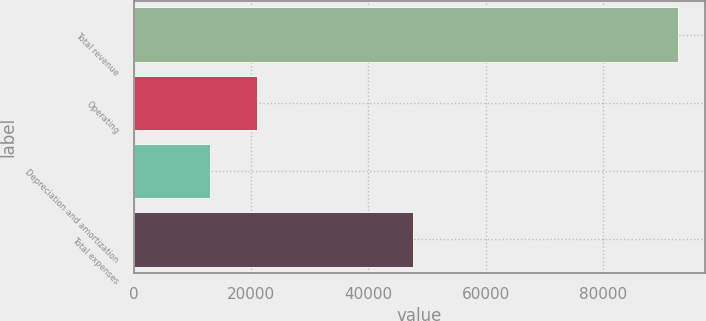Convert chart. <chart><loc_0><loc_0><loc_500><loc_500><bar_chart><fcel>Total revenue<fcel>Operating<fcel>Depreciation and amortization<fcel>Total expenses<nl><fcel>92789<fcel>21060.8<fcel>13091<fcel>47672<nl></chart> 